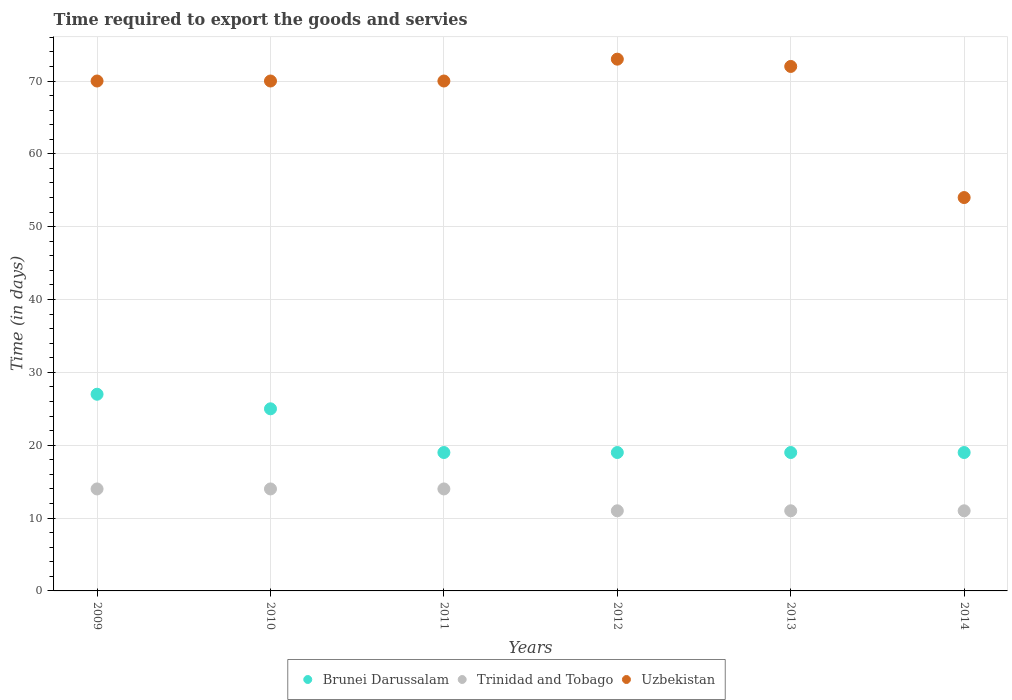What is the number of days required to export the goods and services in Uzbekistan in 2011?
Offer a very short reply. 70. Across all years, what is the minimum number of days required to export the goods and services in Trinidad and Tobago?
Your answer should be compact. 11. In which year was the number of days required to export the goods and services in Brunei Darussalam maximum?
Offer a terse response. 2009. In which year was the number of days required to export the goods and services in Brunei Darussalam minimum?
Give a very brief answer. 2011. What is the total number of days required to export the goods and services in Brunei Darussalam in the graph?
Offer a very short reply. 128. What is the difference between the number of days required to export the goods and services in Trinidad and Tobago in 2011 and that in 2013?
Ensure brevity in your answer.  3. What is the average number of days required to export the goods and services in Uzbekistan per year?
Ensure brevity in your answer.  68.17. In how many years, is the number of days required to export the goods and services in Uzbekistan greater than 24 days?
Your response must be concise. 6. What is the ratio of the number of days required to export the goods and services in Brunei Darussalam in 2009 to that in 2013?
Give a very brief answer. 1.42. Is the difference between the number of days required to export the goods and services in Uzbekistan in 2011 and 2012 greater than the difference between the number of days required to export the goods and services in Brunei Darussalam in 2011 and 2012?
Provide a succinct answer. No. What is the difference between the highest and the second highest number of days required to export the goods and services in Trinidad and Tobago?
Provide a succinct answer. 0. What is the difference between the highest and the lowest number of days required to export the goods and services in Trinidad and Tobago?
Provide a succinct answer. 3. In how many years, is the number of days required to export the goods and services in Uzbekistan greater than the average number of days required to export the goods and services in Uzbekistan taken over all years?
Keep it short and to the point. 5. Is it the case that in every year, the sum of the number of days required to export the goods and services in Uzbekistan and number of days required to export the goods and services in Brunei Darussalam  is greater than the number of days required to export the goods and services in Trinidad and Tobago?
Your answer should be very brief. Yes. Is the number of days required to export the goods and services in Trinidad and Tobago strictly greater than the number of days required to export the goods and services in Uzbekistan over the years?
Your answer should be very brief. No. Is the number of days required to export the goods and services in Uzbekistan strictly less than the number of days required to export the goods and services in Brunei Darussalam over the years?
Offer a very short reply. No. What is the difference between two consecutive major ticks on the Y-axis?
Ensure brevity in your answer.  10. Are the values on the major ticks of Y-axis written in scientific E-notation?
Your answer should be compact. No. Does the graph contain any zero values?
Provide a succinct answer. No. How many legend labels are there?
Offer a very short reply. 3. What is the title of the graph?
Your answer should be very brief. Time required to export the goods and servies. What is the label or title of the Y-axis?
Your answer should be compact. Time (in days). What is the Time (in days) in Brunei Darussalam in 2009?
Provide a succinct answer. 27. What is the Time (in days) of Uzbekistan in 2009?
Provide a succinct answer. 70. What is the Time (in days) in Brunei Darussalam in 2010?
Your answer should be very brief. 25. What is the Time (in days) of Trinidad and Tobago in 2010?
Provide a succinct answer. 14. What is the Time (in days) in Uzbekistan in 2010?
Your answer should be compact. 70. What is the Time (in days) in Brunei Darussalam in 2011?
Provide a succinct answer. 19. What is the Time (in days) of Trinidad and Tobago in 2011?
Offer a terse response. 14. What is the Time (in days) of Uzbekistan in 2011?
Provide a succinct answer. 70. What is the Time (in days) of Brunei Darussalam in 2012?
Offer a very short reply. 19. What is the Time (in days) in Brunei Darussalam in 2013?
Offer a very short reply. 19. What is the Time (in days) in Uzbekistan in 2013?
Ensure brevity in your answer.  72. What is the Time (in days) of Trinidad and Tobago in 2014?
Give a very brief answer. 11. What is the Time (in days) of Uzbekistan in 2014?
Provide a succinct answer. 54. Across all years, what is the maximum Time (in days) in Brunei Darussalam?
Your response must be concise. 27. Across all years, what is the maximum Time (in days) in Trinidad and Tobago?
Offer a terse response. 14. Across all years, what is the maximum Time (in days) of Uzbekistan?
Your answer should be very brief. 73. Across all years, what is the minimum Time (in days) of Brunei Darussalam?
Offer a terse response. 19. Across all years, what is the minimum Time (in days) of Trinidad and Tobago?
Offer a very short reply. 11. Across all years, what is the minimum Time (in days) of Uzbekistan?
Ensure brevity in your answer.  54. What is the total Time (in days) of Brunei Darussalam in the graph?
Ensure brevity in your answer.  128. What is the total Time (in days) in Trinidad and Tobago in the graph?
Keep it short and to the point. 75. What is the total Time (in days) in Uzbekistan in the graph?
Make the answer very short. 409. What is the difference between the Time (in days) in Uzbekistan in 2009 and that in 2013?
Provide a short and direct response. -2. What is the difference between the Time (in days) of Brunei Darussalam in 2010 and that in 2011?
Your answer should be compact. 6. What is the difference between the Time (in days) in Trinidad and Tobago in 2010 and that in 2011?
Offer a very short reply. 0. What is the difference between the Time (in days) of Uzbekistan in 2010 and that in 2011?
Provide a succinct answer. 0. What is the difference between the Time (in days) in Brunei Darussalam in 2010 and that in 2012?
Provide a short and direct response. 6. What is the difference between the Time (in days) in Trinidad and Tobago in 2010 and that in 2012?
Your answer should be compact. 3. What is the difference between the Time (in days) in Trinidad and Tobago in 2010 and that in 2013?
Offer a terse response. 3. What is the difference between the Time (in days) of Uzbekistan in 2010 and that in 2013?
Offer a terse response. -2. What is the difference between the Time (in days) in Brunei Darussalam in 2010 and that in 2014?
Your answer should be very brief. 6. What is the difference between the Time (in days) of Brunei Darussalam in 2011 and that in 2012?
Offer a very short reply. 0. What is the difference between the Time (in days) of Trinidad and Tobago in 2011 and that in 2012?
Make the answer very short. 3. What is the difference between the Time (in days) in Brunei Darussalam in 2011 and that in 2013?
Keep it short and to the point. 0. What is the difference between the Time (in days) in Trinidad and Tobago in 2011 and that in 2013?
Ensure brevity in your answer.  3. What is the difference between the Time (in days) in Uzbekistan in 2011 and that in 2013?
Your answer should be very brief. -2. What is the difference between the Time (in days) of Trinidad and Tobago in 2011 and that in 2014?
Provide a short and direct response. 3. What is the difference between the Time (in days) of Uzbekistan in 2011 and that in 2014?
Offer a terse response. 16. What is the difference between the Time (in days) in Brunei Darussalam in 2012 and that in 2013?
Offer a terse response. 0. What is the difference between the Time (in days) in Trinidad and Tobago in 2012 and that in 2013?
Make the answer very short. 0. What is the difference between the Time (in days) of Brunei Darussalam in 2012 and that in 2014?
Your answer should be compact. 0. What is the difference between the Time (in days) of Uzbekistan in 2013 and that in 2014?
Ensure brevity in your answer.  18. What is the difference between the Time (in days) in Brunei Darussalam in 2009 and the Time (in days) in Trinidad and Tobago in 2010?
Ensure brevity in your answer.  13. What is the difference between the Time (in days) in Brunei Darussalam in 2009 and the Time (in days) in Uzbekistan in 2010?
Provide a short and direct response. -43. What is the difference between the Time (in days) of Trinidad and Tobago in 2009 and the Time (in days) of Uzbekistan in 2010?
Ensure brevity in your answer.  -56. What is the difference between the Time (in days) of Brunei Darussalam in 2009 and the Time (in days) of Uzbekistan in 2011?
Provide a succinct answer. -43. What is the difference between the Time (in days) in Trinidad and Tobago in 2009 and the Time (in days) in Uzbekistan in 2011?
Keep it short and to the point. -56. What is the difference between the Time (in days) in Brunei Darussalam in 2009 and the Time (in days) in Uzbekistan in 2012?
Provide a succinct answer. -46. What is the difference between the Time (in days) of Trinidad and Tobago in 2009 and the Time (in days) of Uzbekistan in 2012?
Your answer should be compact. -59. What is the difference between the Time (in days) of Brunei Darussalam in 2009 and the Time (in days) of Trinidad and Tobago in 2013?
Your response must be concise. 16. What is the difference between the Time (in days) of Brunei Darussalam in 2009 and the Time (in days) of Uzbekistan in 2013?
Your answer should be very brief. -45. What is the difference between the Time (in days) of Trinidad and Tobago in 2009 and the Time (in days) of Uzbekistan in 2013?
Provide a short and direct response. -58. What is the difference between the Time (in days) in Brunei Darussalam in 2009 and the Time (in days) in Trinidad and Tobago in 2014?
Your response must be concise. 16. What is the difference between the Time (in days) of Trinidad and Tobago in 2009 and the Time (in days) of Uzbekistan in 2014?
Keep it short and to the point. -40. What is the difference between the Time (in days) in Brunei Darussalam in 2010 and the Time (in days) in Uzbekistan in 2011?
Provide a succinct answer. -45. What is the difference between the Time (in days) in Trinidad and Tobago in 2010 and the Time (in days) in Uzbekistan in 2011?
Your response must be concise. -56. What is the difference between the Time (in days) of Brunei Darussalam in 2010 and the Time (in days) of Uzbekistan in 2012?
Ensure brevity in your answer.  -48. What is the difference between the Time (in days) of Trinidad and Tobago in 2010 and the Time (in days) of Uzbekistan in 2012?
Give a very brief answer. -59. What is the difference between the Time (in days) of Brunei Darussalam in 2010 and the Time (in days) of Trinidad and Tobago in 2013?
Keep it short and to the point. 14. What is the difference between the Time (in days) in Brunei Darussalam in 2010 and the Time (in days) in Uzbekistan in 2013?
Give a very brief answer. -47. What is the difference between the Time (in days) of Trinidad and Tobago in 2010 and the Time (in days) of Uzbekistan in 2013?
Offer a very short reply. -58. What is the difference between the Time (in days) of Brunei Darussalam in 2010 and the Time (in days) of Trinidad and Tobago in 2014?
Offer a terse response. 14. What is the difference between the Time (in days) of Brunei Darussalam in 2011 and the Time (in days) of Uzbekistan in 2012?
Ensure brevity in your answer.  -54. What is the difference between the Time (in days) of Trinidad and Tobago in 2011 and the Time (in days) of Uzbekistan in 2012?
Ensure brevity in your answer.  -59. What is the difference between the Time (in days) in Brunei Darussalam in 2011 and the Time (in days) in Trinidad and Tobago in 2013?
Provide a short and direct response. 8. What is the difference between the Time (in days) of Brunei Darussalam in 2011 and the Time (in days) of Uzbekistan in 2013?
Your answer should be very brief. -53. What is the difference between the Time (in days) in Trinidad and Tobago in 2011 and the Time (in days) in Uzbekistan in 2013?
Give a very brief answer. -58. What is the difference between the Time (in days) in Brunei Darussalam in 2011 and the Time (in days) in Trinidad and Tobago in 2014?
Make the answer very short. 8. What is the difference between the Time (in days) in Brunei Darussalam in 2011 and the Time (in days) in Uzbekistan in 2014?
Provide a short and direct response. -35. What is the difference between the Time (in days) of Brunei Darussalam in 2012 and the Time (in days) of Trinidad and Tobago in 2013?
Provide a short and direct response. 8. What is the difference between the Time (in days) in Brunei Darussalam in 2012 and the Time (in days) in Uzbekistan in 2013?
Provide a short and direct response. -53. What is the difference between the Time (in days) of Trinidad and Tobago in 2012 and the Time (in days) of Uzbekistan in 2013?
Offer a terse response. -61. What is the difference between the Time (in days) in Brunei Darussalam in 2012 and the Time (in days) in Trinidad and Tobago in 2014?
Give a very brief answer. 8. What is the difference between the Time (in days) in Brunei Darussalam in 2012 and the Time (in days) in Uzbekistan in 2014?
Provide a succinct answer. -35. What is the difference between the Time (in days) of Trinidad and Tobago in 2012 and the Time (in days) of Uzbekistan in 2014?
Offer a terse response. -43. What is the difference between the Time (in days) of Brunei Darussalam in 2013 and the Time (in days) of Uzbekistan in 2014?
Ensure brevity in your answer.  -35. What is the difference between the Time (in days) of Trinidad and Tobago in 2013 and the Time (in days) of Uzbekistan in 2014?
Make the answer very short. -43. What is the average Time (in days) of Brunei Darussalam per year?
Offer a terse response. 21.33. What is the average Time (in days) of Trinidad and Tobago per year?
Ensure brevity in your answer.  12.5. What is the average Time (in days) in Uzbekistan per year?
Your answer should be very brief. 68.17. In the year 2009, what is the difference between the Time (in days) of Brunei Darussalam and Time (in days) of Uzbekistan?
Offer a terse response. -43. In the year 2009, what is the difference between the Time (in days) of Trinidad and Tobago and Time (in days) of Uzbekistan?
Ensure brevity in your answer.  -56. In the year 2010, what is the difference between the Time (in days) of Brunei Darussalam and Time (in days) of Trinidad and Tobago?
Keep it short and to the point. 11. In the year 2010, what is the difference between the Time (in days) of Brunei Darussalam and Time (in days) of Uzbekistan?
Provide a short and direct response. -45. In the year 2010, what is the difference between the Time (in days) of Trinidad and Tobago and Time (in days) of Uzbekistan?
Give a very brief answer. -56. In the year 2011, what is the difference between the Time (in days) of Brunei Darussalam and Time (in days) of Uzbekistan?
Offer a very short reply. -51. In the year 2011, what is the difference between the Time (in days) of Trinidad and Tobago and Time (in days) of Uzbekistan?
Ensure brevity in your answer.  -56. In the year 2012, what is the difference between the Time (in days) of Brunei Darussalam and Time (in days) of Uzbekistan?
Ensure brevity in your answer.  -54. In the year 2012, what is the difference between the Time (in days) of Trinidad and Tobago and Time (in days) of Uzbekistan?
Provide a short and direct response. -62. In the year 2013, what is the difference between the Time (in days) of Brunei Darussalam and Time (in days) of Uzbekistan?
Your answer should be compact. -53. In the year 2013, what is the difference between the Time (in days) of Trinidad and Tobago and Time (in days) of Uzbekistan?
Your response must be concise. -61. In the year 2014, what is the difference between the Time (in days) of Brunei Darussalam and Time (in days) of Uzbekistan?
Provide a short and direct response. -35. In the year 2014, what is the difference between the Time (in days) of Trinidad and Tobago and Time (in days) of Uzbekistan?
Your answer should be very brief. -43. What is the ratio of the Time (in days) in Trinidad and Tobago in 2009 to that in 2010?
Give a very brief answer. 1. What is the ratio of the Time (in days) of Uzbekistan in 2009 to that in 2010?
Your response must be concise. 1. What is the ratio of the Time (in days) of Brunei Darussalam in 2009 to that in 2011?
Your answer should be very brief. 1.42. What is the ratio of the Time (in days) of Trinidad and Tobago in 2009 to that in 2011?
Make the answer very short. 1. What is the ratio of the Time (in days) in Brunei Darussalam in 2009 to that in 2012?
Your answer should be very brief. 1.42. What is the ratio of the Time (in days) in Trinidad and Tobago in 2009 to that in 2012?
Make the answer very short. 1.27. What is the ratio of the Time (in days) of Uzbekistan in 2009 to that in 2012?
Provide a short and direct response. 0.96. What is the ratio of the Time (in days) of Brunei Darussalam in 2009 to that in 2013?
Provide a short and direct response. 1.42. What is the ratio of the Time (in days) of Trinidad and Tobago in 2009 to that in 2013?
Offer a very short reply. 1.27. What is the ratio of the Time (in days) of Uzbekistan in 2009 to that in 2013?
Your response must be concise. 0.97. What is the ratio of the Time (in days) of Brunei Darussalam in 2009 to that in 2014?
Your answer should be very brief. 1.42. What is the ratio of the Time (in days) of Trinidad and Tobago in 2009 to that in 2014?
Your response must be concise. 1.27. What is the ratio of the Time (in days) of Uzbekistan in 2009 to that in 2014?
Provide a succinct answer. 1.3. What is the ratio of the Time (in days) in Brunei Darussalam in 2010 to that in 2011?
Offer a very short reply. 1.32. What is the ratio of the Time (in days) in Trinidad and Tobago in 2010 to that in 2011?
Your answer should be very brief. 1. What is the ratio of the Time (in days) in Brunei Darussalam in 2010 to that in 2012?
Provide a succinct answer. 1.32. What is the ratio of the Time (in days) in Trinidad and Tobago in 2010 to that in 2012?
Your answer should be compact. 1.27. What is the ratio of the Time (in days) in Uzbekistan in 2010 to that in 2012?
Provide a short and direct response. 0.96. What is the ratio of the Time (in days) of Brunei Darussalam in 2010 to that in 2013?
Your response must be concise. 1.32. What is the ratio of the Time (in days) of Trinidad and Tobago in 2010 to that in 2013?
Offer a very short reply. 1.27. What is the ratio of the Time (in days) of Uzbekistan in 2010 to that in 2013?
Make the answer very short. 0.97. What is the ratio of the Time (in days) in Brunei Darussalam in 2010 to that in 2014?
Offer a terse response. 1.32. What is the ratio of the Time (in days) in Trinidad and Tobago in 2010 to that in 2014?
Your answer should be compact. 1.27. What is the ratio of the Time (in days) in Uzbekistan in 2010 to that in 2014?
Make the answer very short. 1.3. What is the ratio of the Time (in days) in Trinidad and Tobago in 2011 to that in 2012?
Your answer should be compact. 1.27. What is the ratio of the Time (in days) in Uzbekistan in 2011 to that in 2012?
Your response must be concise. 0.96. What is the ratio of the Time (in days) of Trinidad and Tobago in 2011 to that in 2013?
Give a very brief answer. 1.27. What is the ratio of the Time (in days) in Uzbekistan in 2011 to that in 2013?
Keep it short and to the point. 0.97. What is the ratio of the Time (in days) in Trinidad and Tobago in 2011 to that in 2014?
Ensure brevity in your answer.  1.27. What is the ratio of the Time (in days) in Uzbekistan in 2011 to that in 2014?
Your answer should be compact. 1.3. What is the ratio of the Time (in days) in Uzbekistan in 2012 to that in 2013?
Offer a terse response. 1.01. What is the ratio of the Time (in days) of Brunei Darussalam in 2012 to that in 2014?
Your answer should be compact. 1. What is the ratio of the Time (in days) of Uzbekistan in 2012 to that in 2014?
Your answer should be compact. 1.35. What is the ratio of the Time (in days) of Brunei Darussalam in 2013 to that in 2014?
Offer a terse response. 1. What is the ratio of the Time (in days) in Uzbekistan in 2013 to that in 2014?
Ensure brevity in your answer.  1.33. What is the difference between the highest and the second highest Time (in days) of Trinidad and Tobago?
Your answer should be compact. 0. What is the difference between the highest and the second highest Time (in days) of Uzbekistan?
Make the answer very short. 1. What is the difference between the highest and the lowest Time (in days) of Brunei Darussalam?
Your answer should be compact. 8. What is the difference between the highest and the lowest Time (in days) of Uzbekistan?
Make the answer very short. 19. 